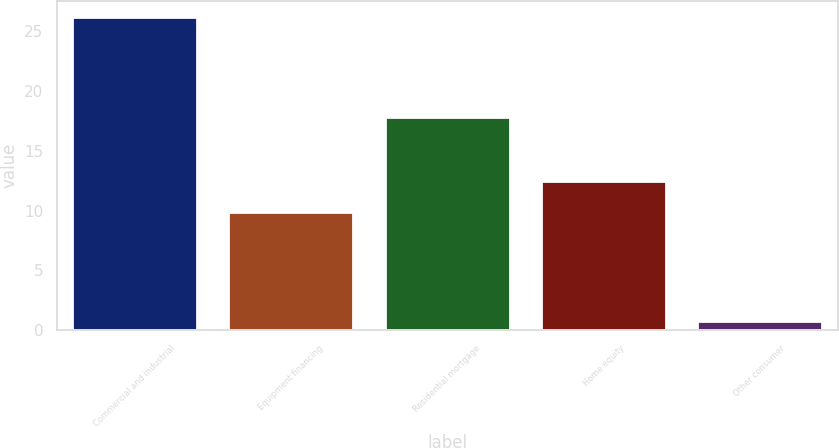<chart> <loc_0><loc_0><loc_500><loc_500><bar_chart><fcel>Commercial and industrial<fcel>Equipment financing<fcel>Residential mortgage<fcel>Home equity<fcel>Other consumer<nl><fcel>26.2<fcel>9.9<fcel>17.8<fcel>12.44<fcel>0.8<nl></chart> 